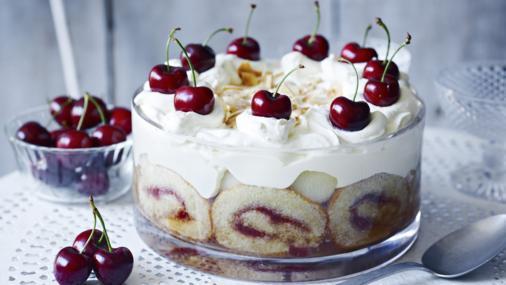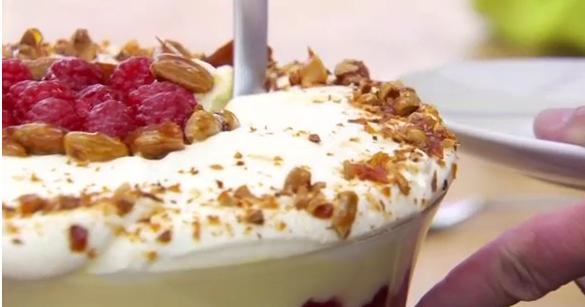The first image is the image on the left, the second image is the image on the right. Considering the images on both sides, is "All of the trifles are topped with blueberries or raspberries." valid? Answer yes or no. No. The first image is the image on the left, the second image is the image on the right. Considering the images on both sides, is "the desserts have rolled up cake involved" valid? Answer yes or no. Yes. 